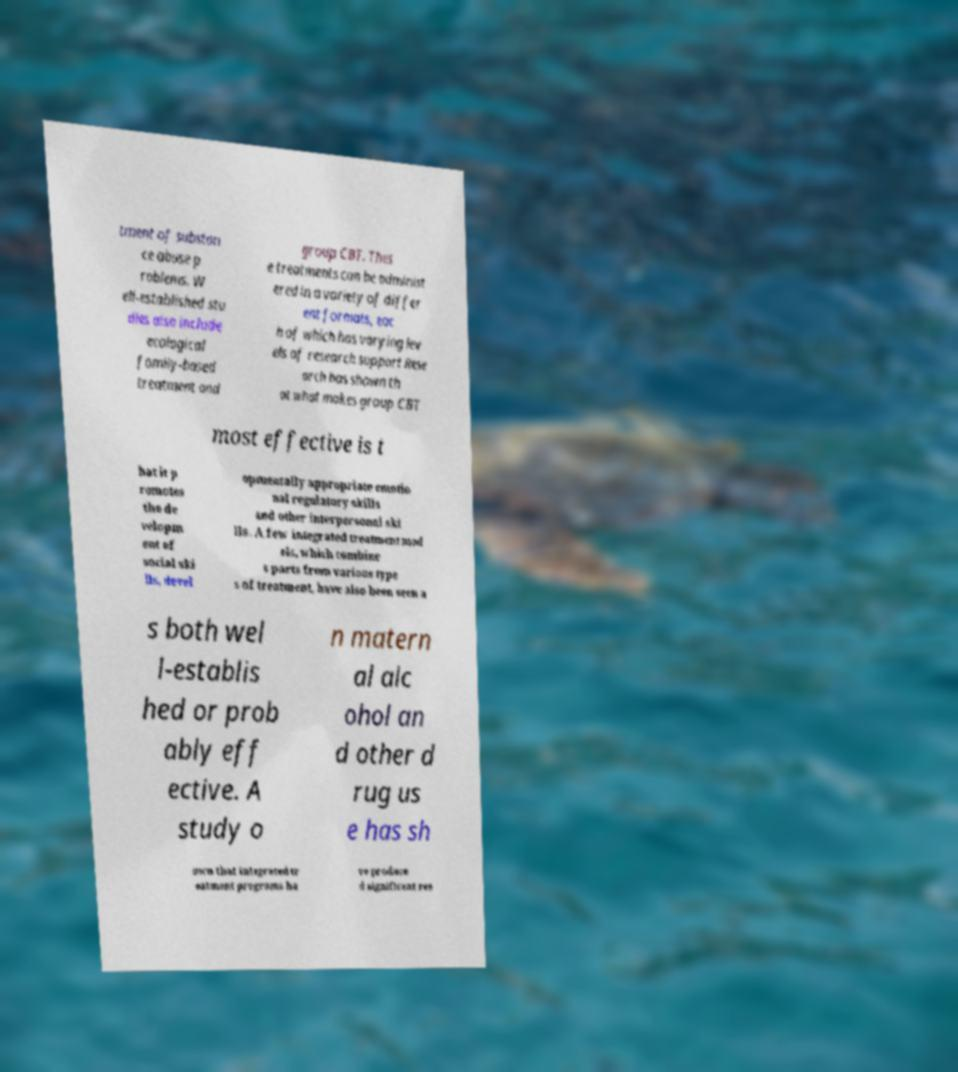For documentation purposes, I need the text within this image transcribed. Could you provide that? tment of substan ce abuse p roblems. W ell-established stu dies also include ecological family-based treatment and group CBT. Thes e treatments can be administ ered in a variety of differ ent formats, eac h of which has varying lev els of research support Rese arch has shown th at what makes group CBT most effective is t hat it p romotes the de velopm ent of social ski lls, devel opmentally appropriate emotio nal regulatory skills and other interpersonal ski lls. A few integrated treatment mod els, which combine s parts from various type s of treatment, have also been seen a s both wel l-establis hed or prob ably eff ective. A study o n matern al alc ohol an d other d rug us e has sh own that integrated tr eatment programs ha ve produce d significant res 